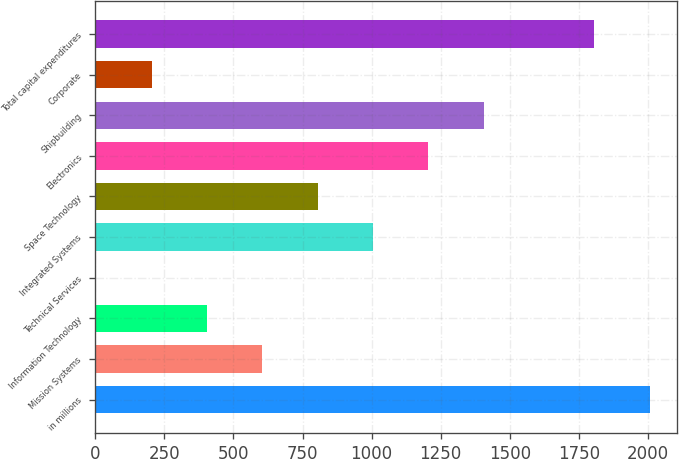<chart> <loc_0><loc_0><loc_500><loc_500><bar_chart><fcel>in millions<fcel>Mission Systems<fcel>Information Technology<fcel>Technical Services<fcel>Integrated Systems<fcel>Space Technology<fcel>Electronics<fcel>Shipbuilding<fcel>Corporate<fcel>Total capital expenditures<nl><fcel>2006<fcel>604.6<fcel>404.4<fcel>4<fcel>1005<fcel>804.8<fcel>1205.2<fcel>1405.4<fcel>204.2<fcel>1805.8<nl></chart> 